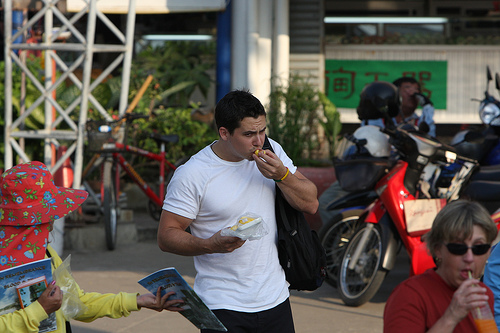<image>
Is there a shirt under the person? No. The shirt is not positioned under the person. The vertical relationship between these objects is different. 